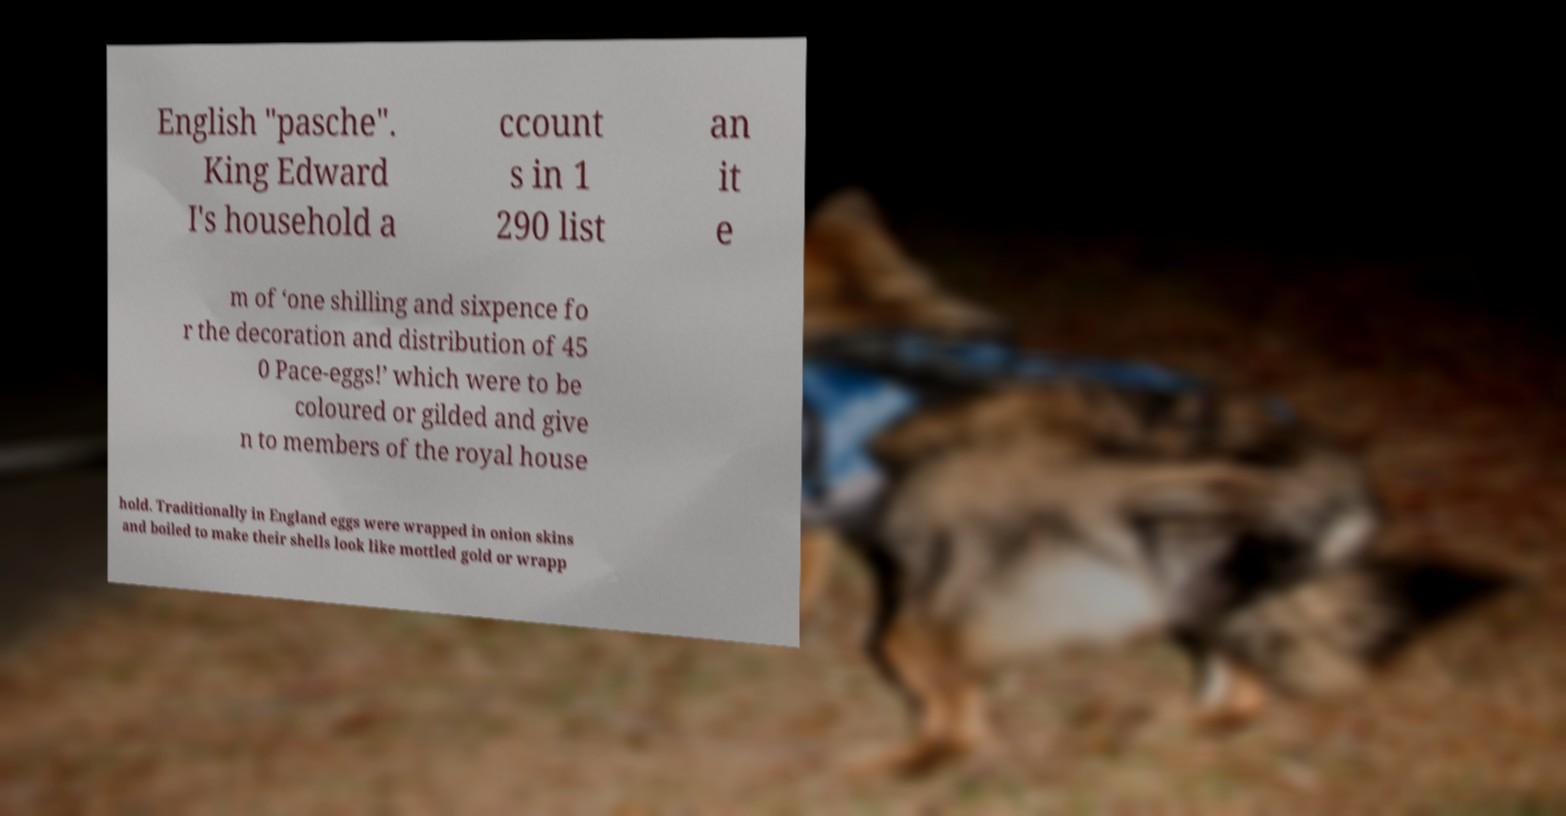What messages or text are displayed in this image? I need them in a readable, typed format. English "pasche". King Edward I's household a ccount s in 1 290 list an it e m of ‘one shilling and sixpence fo r the decoration and distribution of 45 0 Pace-eggs!’ which were to be coloured or gilded and give n to members of the royal house hold. Traditionally in England eggs were wrapped in onion skins and boiled to make their shells look like mottled gold or wrapp 